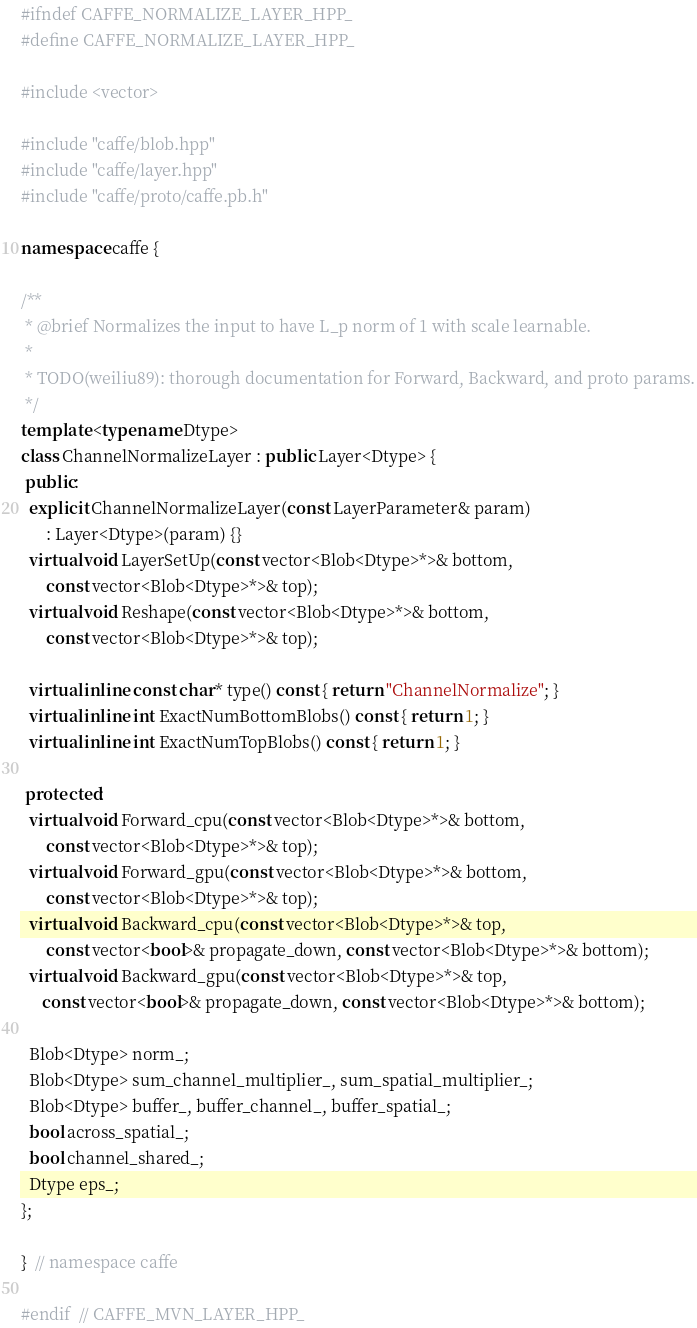Convert code to text. <code><loc_0><loc_0><loc_500><loc_500><_C++_>#ifndef CAFFE_NORMALIZE_LAYER_HPP_
#define CAFFE_NORMALIZE_LAYER_HPP_

#include <vector>

#include "caffe/blob.hpp"
#include "caffe/layer.hpp"
#include "caffe/proto/caffe.pb.h"

namespace caffe {

/**
 * @brief Normalizes the input to have L_p norm of 1 with scale learnable.
 *
 * TODO(weiliu89): thorough documentation for Forward, Backward, and proto params.
 */
template <typename Dtype>
class ChannelNormalizeLayer : public Layer<Dtype> {
 public:
  explicit ChannelNormalizeLayer(const LayerParameter& param)
      : Layer<Dtype>(param) {}
  virtual void LayerSetUp(const vector<Blob<Dtype>*>& bottom,
      const vector<Blob<Dtype>*>& top);
  virtual void Reshape(const vector<Blob<Dtype>*>& bottom,
      const vector<Blob<Dtype>*>& top);

  virtual inline const char* type() const { return "ChannelNormalize"; }
  virtual inline int ExactNumBottomBlobs() const { return 1; }
  virtual inline int ExactNumTopBlobs() const { return 1; }

 protected:
  virtual void Forward_cpu(const vector<Blob<Dtype>*>& bottom,
      const vector<Blob<Dtype>*>& top);
  virtual void Forward_gpu(const vector<Blob<Dtype>*>& bottom,
      const vector<Blob<Dtype>*>& top);
  virtual void Backward_cpu(const vector<Blob<Dtype>*>& top,
      const vector<bool>& propagate_down, const vector<Blob<Dtype>*>& bottom);
  virtual void Backward_gpu(const vector<Blob<Dtype>*>& top,
     const vector<bool>& propagate_down, const vector<Blob<Dtype>*>& bottom);

  Blob<Dtype> norm_;
  Blob<Dtype> sum_channel_multiplier_, sum_spatial_multiplier_;
  Blob<Dtype> buffer_, buffer_channel_, buffer_spatial_;
  bool across_spatial_;
  bool channel_shared_;
  Dtype eps_;
};

}  // namespace caffe

#endif  // CAFFE_MVN_LAYER_HPP_
</code> 